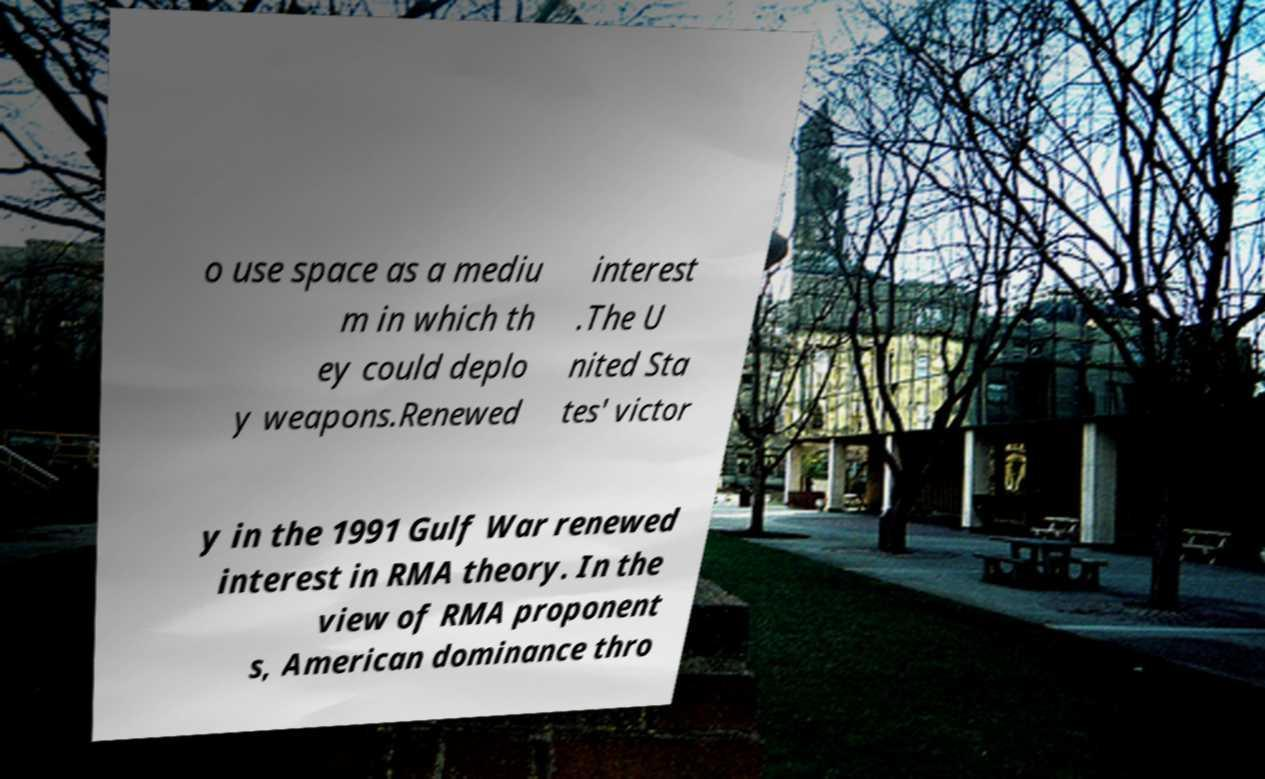For documentation purposes, I need the text within this image transcribed. Could you provide that? o use space as a mediu m in which th ey could deplo y weapons.Renewed interest .The U nited Sta tes' victor y in the 1991 Gulf War renewed interest in RMA theory. In the view of RMA proponent s, American dominance thro 